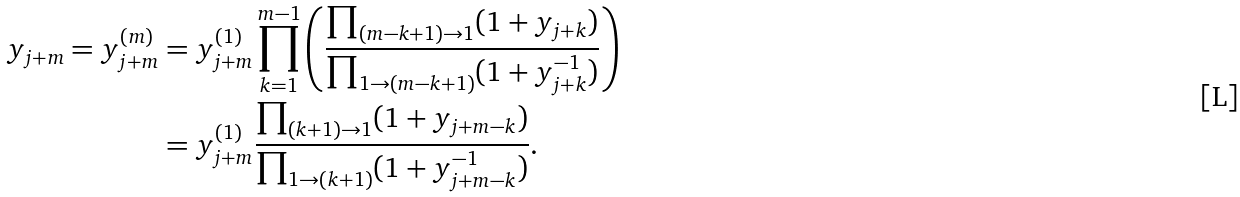<formula> <loc_0><loc_0><loc_500><loc_500>y _ { j + m } = y _ { j + m } ^ { ( m ) } & = y _ { j + m } ^ { ( 1 ) } \prod _ { k = 1 } ^ { m - 1 } \left ( \frac { \prod _ { ( m - k + 1 ) \rightarrow 1 } ( 1 + y _ { j + k } ) } { \prod _ { 1 \rightarrow ( m - k + 1 ) } ( 1 + y _ { j + k } ^ { - 1 } ) } \right ) \\ & = y _ { j + m } ^ { ( 1 ) } \frac { \prod _ { ( k + 1 ) \rightarrow 1 } ( 1 + y _ { j + m - k } ) } { \prod _ { 1 \rightarrow ( k + 1 ) } ( 1 + y _ { j + m - k } ^ { - 1 } ) } .</formula> 